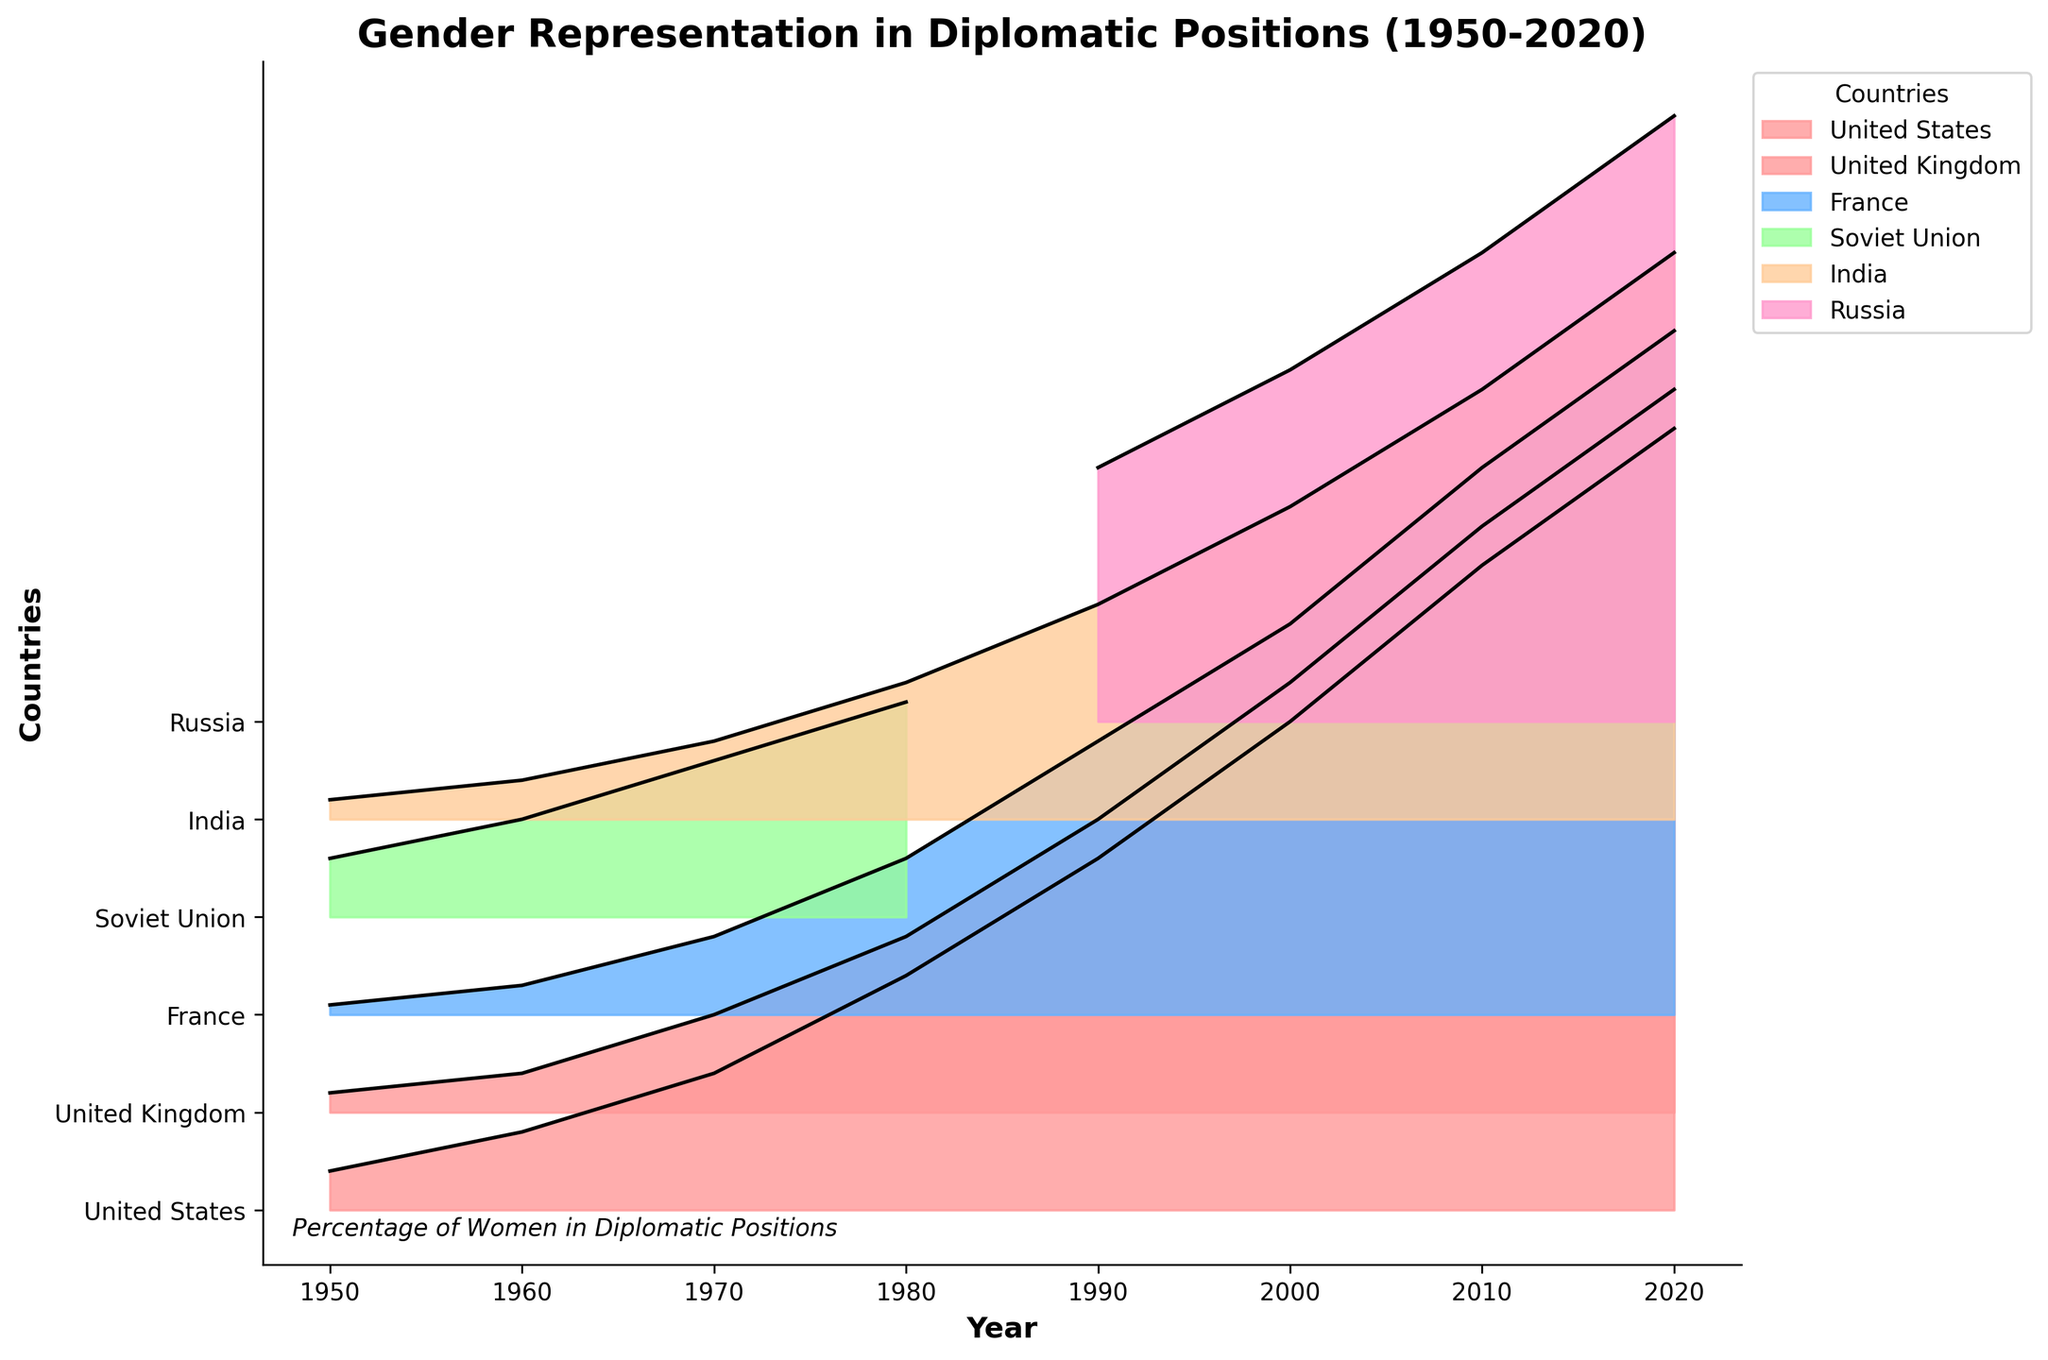What's the title of the figure? The title of the figure is prominently displayed at the top of the plot.
Answer: Gender Representation in Diplomatic Positions (1950-2020) Which country had the lowest gender representation in 1950? To find this, compare the percentages for all countries in 1950. France had the lowest percentage of 0.5%.
Answer: France How did the percentage of women in diplomatic positions in the United States change from 1950 to 2020? Observe the percentage value for the United States in 1950 and 2020. In 1950, it was 2%, and in 2020, it increased to 40%.
Answer: Increased by 38 percentage points Which country showed the most consistent increase in gender representation over the decades? Visually inspect the plot for a steady upward trend across all decades. The United States shows a consistent increase across the decades.
Answer: United States What is the difference in the percentage of women in diplomatic positions between India and France in 2020? Locate the values for India and France in 2020 and compute the difference. India has 29% and France has 35%, so the difference is 35% - 29% = 6%.
Answer: 6% Between which consecutive decades did the Soviet Union/Russia show the greatest increase in gender representation? Compare percentage values for consecutive decades. The largest increase is from 1960 (5%) to 1970 (8%), an increase of 3 percentage points.
Answer: 1960 to 1970 Which country had the largest percentage of women in diplomatic positions in 2010? Check the percentage values for 2010 for all countries. The United States had the highest percentage at 33%.
Answer: United States Between 1950 and 2020, which country had the highest annual average increase in gender representation in diplomatic positions? Calculate the total increase over the years for each country and divide by the number of decades (7). The United States had an increase from 2% to 40%, which is 38% over 7 decades, resulting in an average increase of about 5.43% per decade.
Answer: United States In 1990, which two countries had similar gender representation percentages? Compare the 1990 percentages for all countries. France (14%) and Russia (13%) had similar percentages.
Answer: France and Russia 